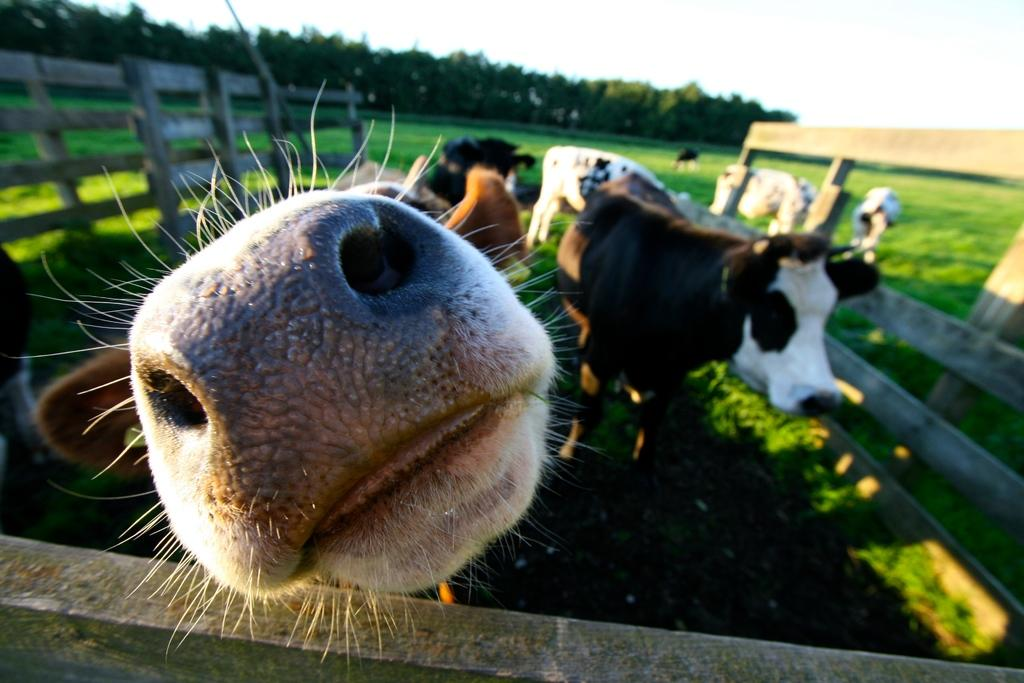What is located in the center of the image? There are animals in the center of the image. What can be seen surrounding the animals? There is a fence in the image. What type of natural environment is visible in the background of the image? There are trees in the background of the image. What part of the natural environment is visible in the background of the image? The sky is visible in the background of the image. What type of pie is being served on the bed in the image? There is no pie or bed present in the image; it features animals and a fence. 